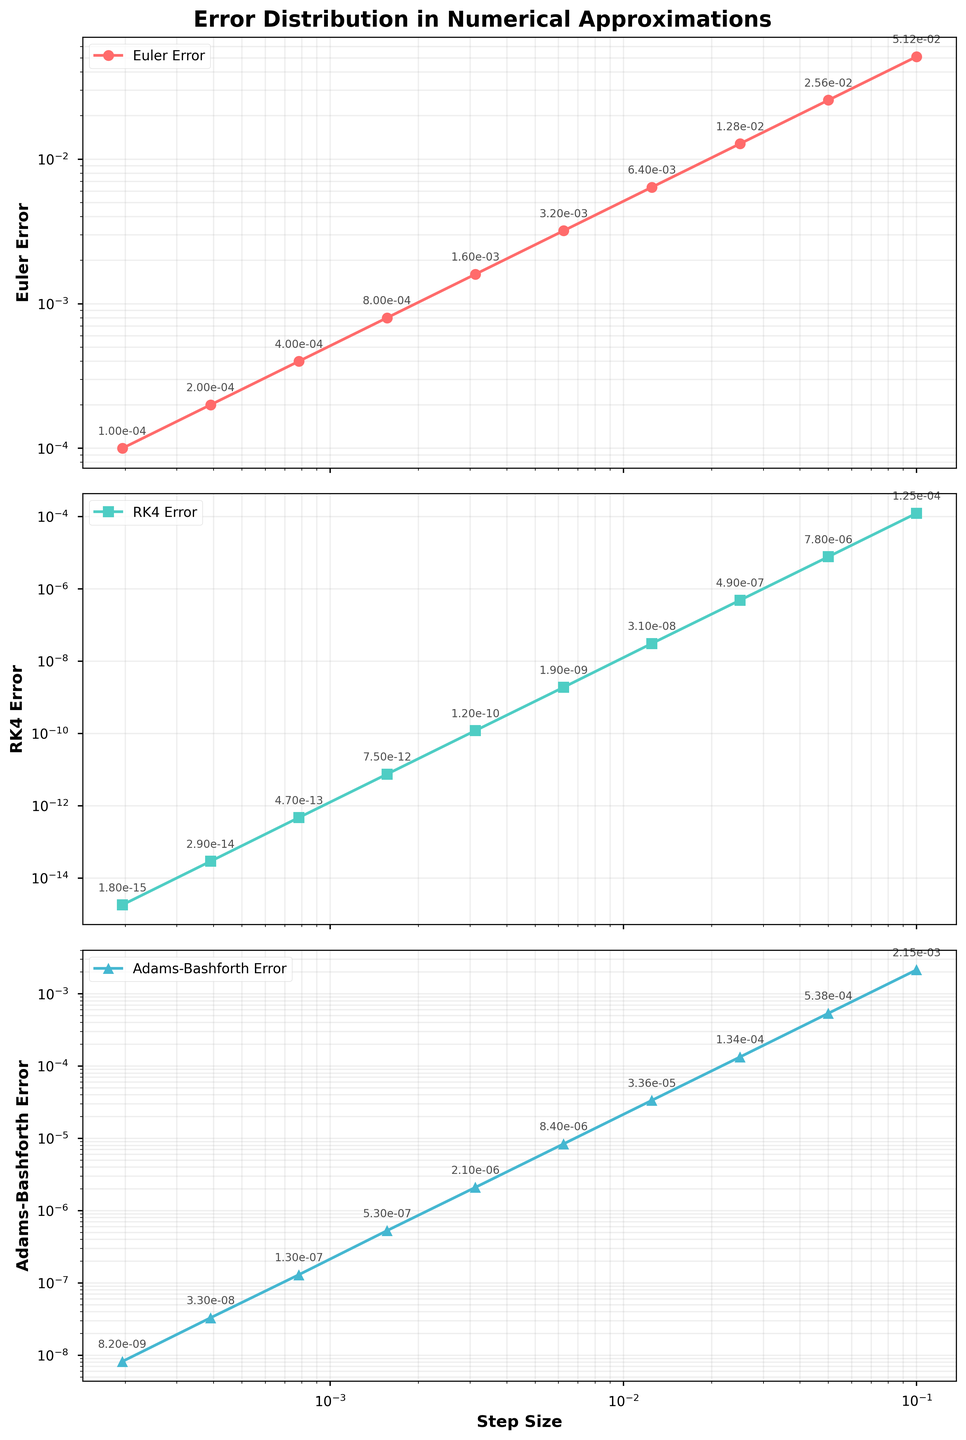Which method has the largest error for a step size of 0.1? Look at the plot for the step size of 0.1 on each subplot. The Euler method shows the highest error compared to RK4 and Adams-Bashforth.
Answer: Euler method How does the error of the RK4 method compare to the Euler method for the smallest step size? Examine the error values at the smallest step size (0.0001953125) on both the RK4 and Euler subplots. RK4 error is drastically smaller than Euler error.
Answer: RK4 error is drastically smaller Which method shows the steepest slope of error reduction as the step size decreases? Visually inspect how much the error line declines in each subplot. The RK4 subplot shows the most rapid decline in error as the step size decreases.
Answer: RK4 method What is the difference in error between the Euler and Adams-Bashforth methods at a step size of 0.05? Find the errors for both methods at a step size of 0.05. For Euler, it's 0.0256 and for Adams-Bashforth, it's 0.000538. Calculate the difference: 0.0256 - 0.000538 = 0.025062
Answer: 0.025062 What color represents the Adams-Bashforth error in the plot? Look at the legend in the subplot and find the color associated with Adams-Bashforth. It's represented in blue.
Answer: Blue Rank the three numerical methods by their errors at the step size of 0.0125, from largest to smallest. At step size 0.0125, note the error values in all three subplots: Euler (0.0064), Adams-Bashforth (0.0000336), and RK4 (0.000000031). Rank them as Euler, Adams-Bashforth, and RK4.
Answer: Euler > Adams-Bashforth > RK4 At what step size does the Adams-Bashforth method's error become less than 10^-4? Look at the Adams-Bashforth subplot to find the step size where the error first goes below 10^-4. This occurs at a step size of 0.025.
Answer: 0.025 How many times smaller is the RK4 error compared to the Euler error at a step size of 0.003125? Check both errors at this step size: Euler (0.0016) and RK4 (0.00000000012). Divide Euler's error by RK4's error: 0.0016 / 0.00000000012 = 13333333.33
Answer: 13333333.33 Which method has the smallest final error at the smallest step size? Compare the final errors at the smallest step size (0.0001953125) for all methods. RK4 shows the smallest error.
Answer: RK4 method What is the visual characteristic that helps identify errors for the Euler method? Notice the red markers and line in the subplot, which represent the Euler method.
Answer: Red markers and line 